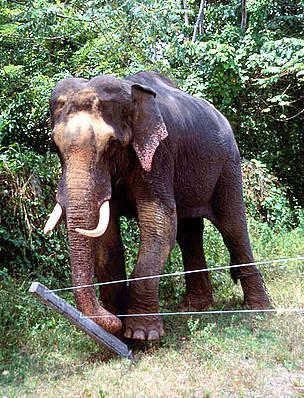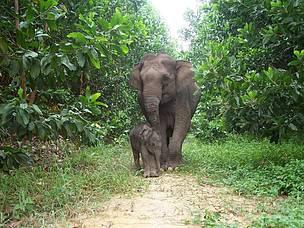The first image is the image on the left, the second image is the image on the right. Assess this claim about the two images: "There are two adult elephants in the image on the right.". Correct or not? Answer yes or no. No. 